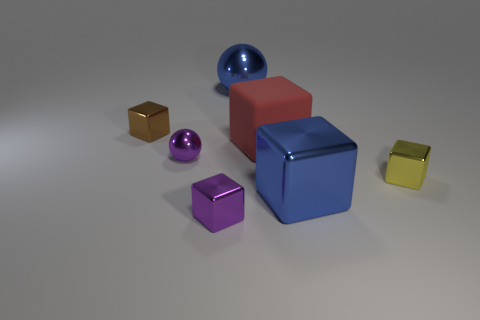What number of other rubber things have the same shape as the big red thing?
Provide a short and direct response. 0. What material is the tiny cube that is the same color as the small ball?
Provide a short and direct response. Metal. Are the purple ball and the yellow object made of the same material?
Keep it short and to the point. Yes. What number of big blue metallic objects are behind the shiny object that is to the right of the big blue thing in front of the tiny brown metallic thing?
Ensure brevity in your answer.  1. Are there any red cubes made of the same material as the tiny yellow object?
Give a very brief answer. No. There is a metallic object that is the same color as the large metallic block; what is its size?
Your response must be concise. Large. Are there fewer purple blocks than tiny brown rubber cylinders?
Keep it short and to the point. No. Is the color of the large block that is behind the tiny sphere the same as the small sphere?
Offer a terse response. No. The large red cube that is in front of the tiny metal thing behind the tiny purple shiny object that is behind the yellow object is made of what material?
Your response must be concise. Rubber. Is there a tiny sphere that has the same color as the big matte block?
Offer a very short reply. No. 